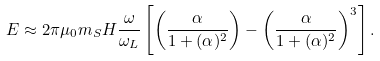<formula> <loc_0><loc_0><loc_500><loc_500>E \approx 2 \pi \mu _ { 0 } m _ { S } H \frac { \omega } { \omega _ { L } } \left [ \left ( \frac { \alpha } { 1 + ( \alpha ) ^ { 2 } } \right ) - \left ( \frac { \alpha } { 1 + ( \alpha ) ^ { 2 } } \right ) ^ { 3 } \right ] .</formula> 